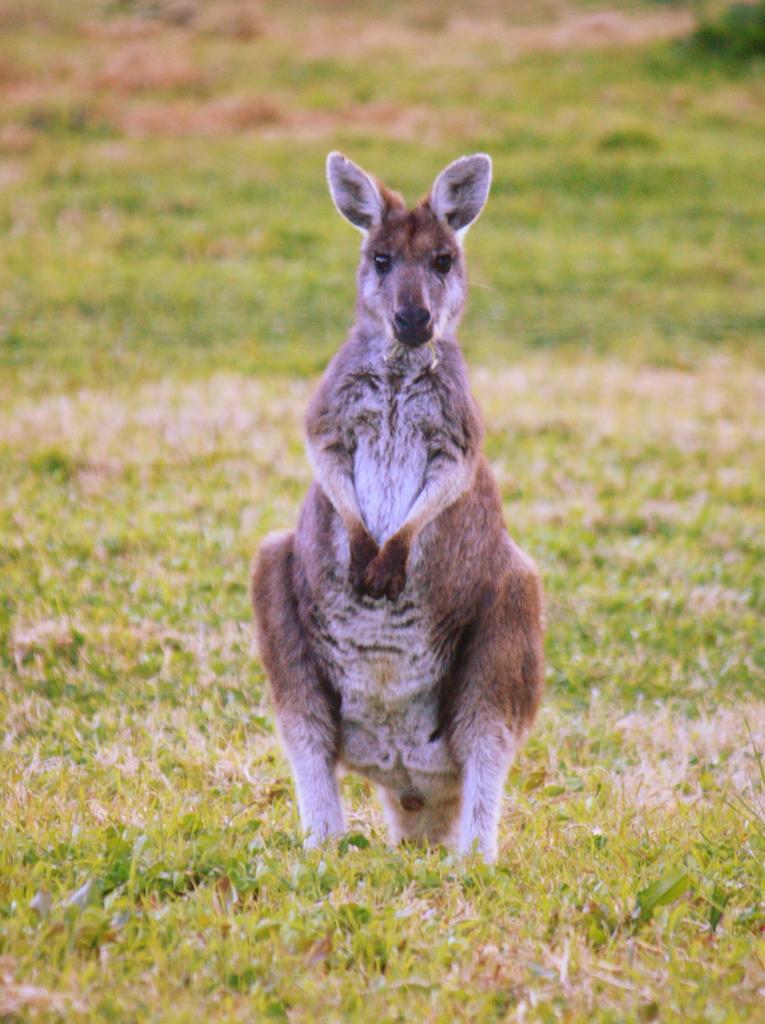In one or two sentences, can you explain what this image depicts? In this picture there is a kangaroo standing. At the bottom there is grass and there is mud. 